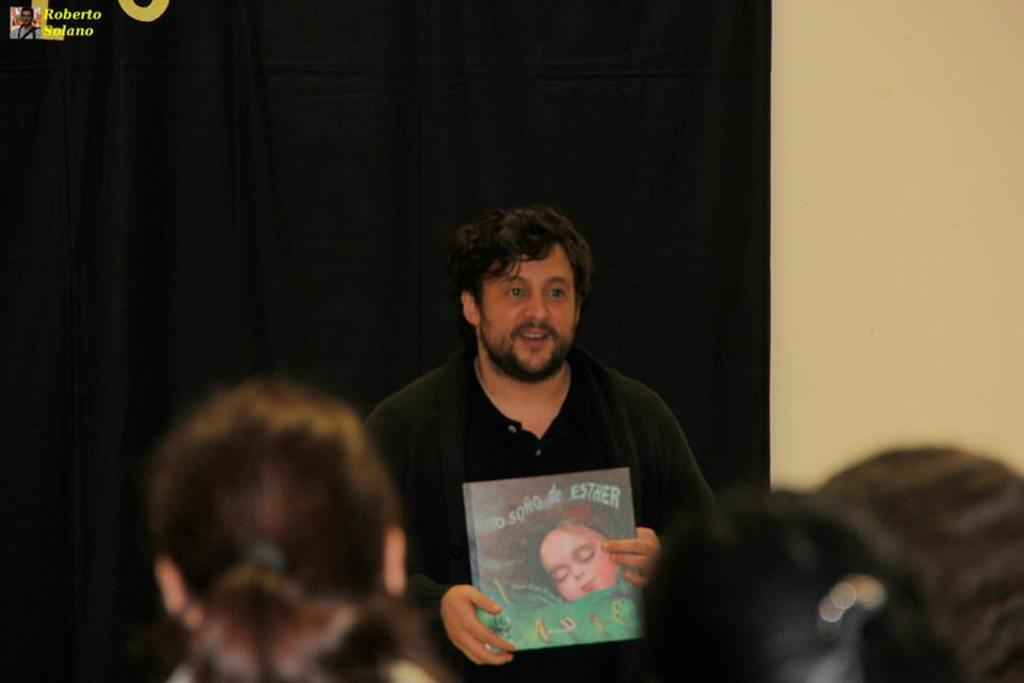How many people are in the image? There are people in the image, but the exact number is not specified. What is one person doing in the image? One person is holding a book in the image. What can be seen in the background of the image? There is a curtain and a wall in the background of the image. Can you read any text in the image? Yes, there is some text visible in the image. How much wealth does the squirrel in the image possess? There is no squirrel present in the image, so it is not possible to determine its wealth. 